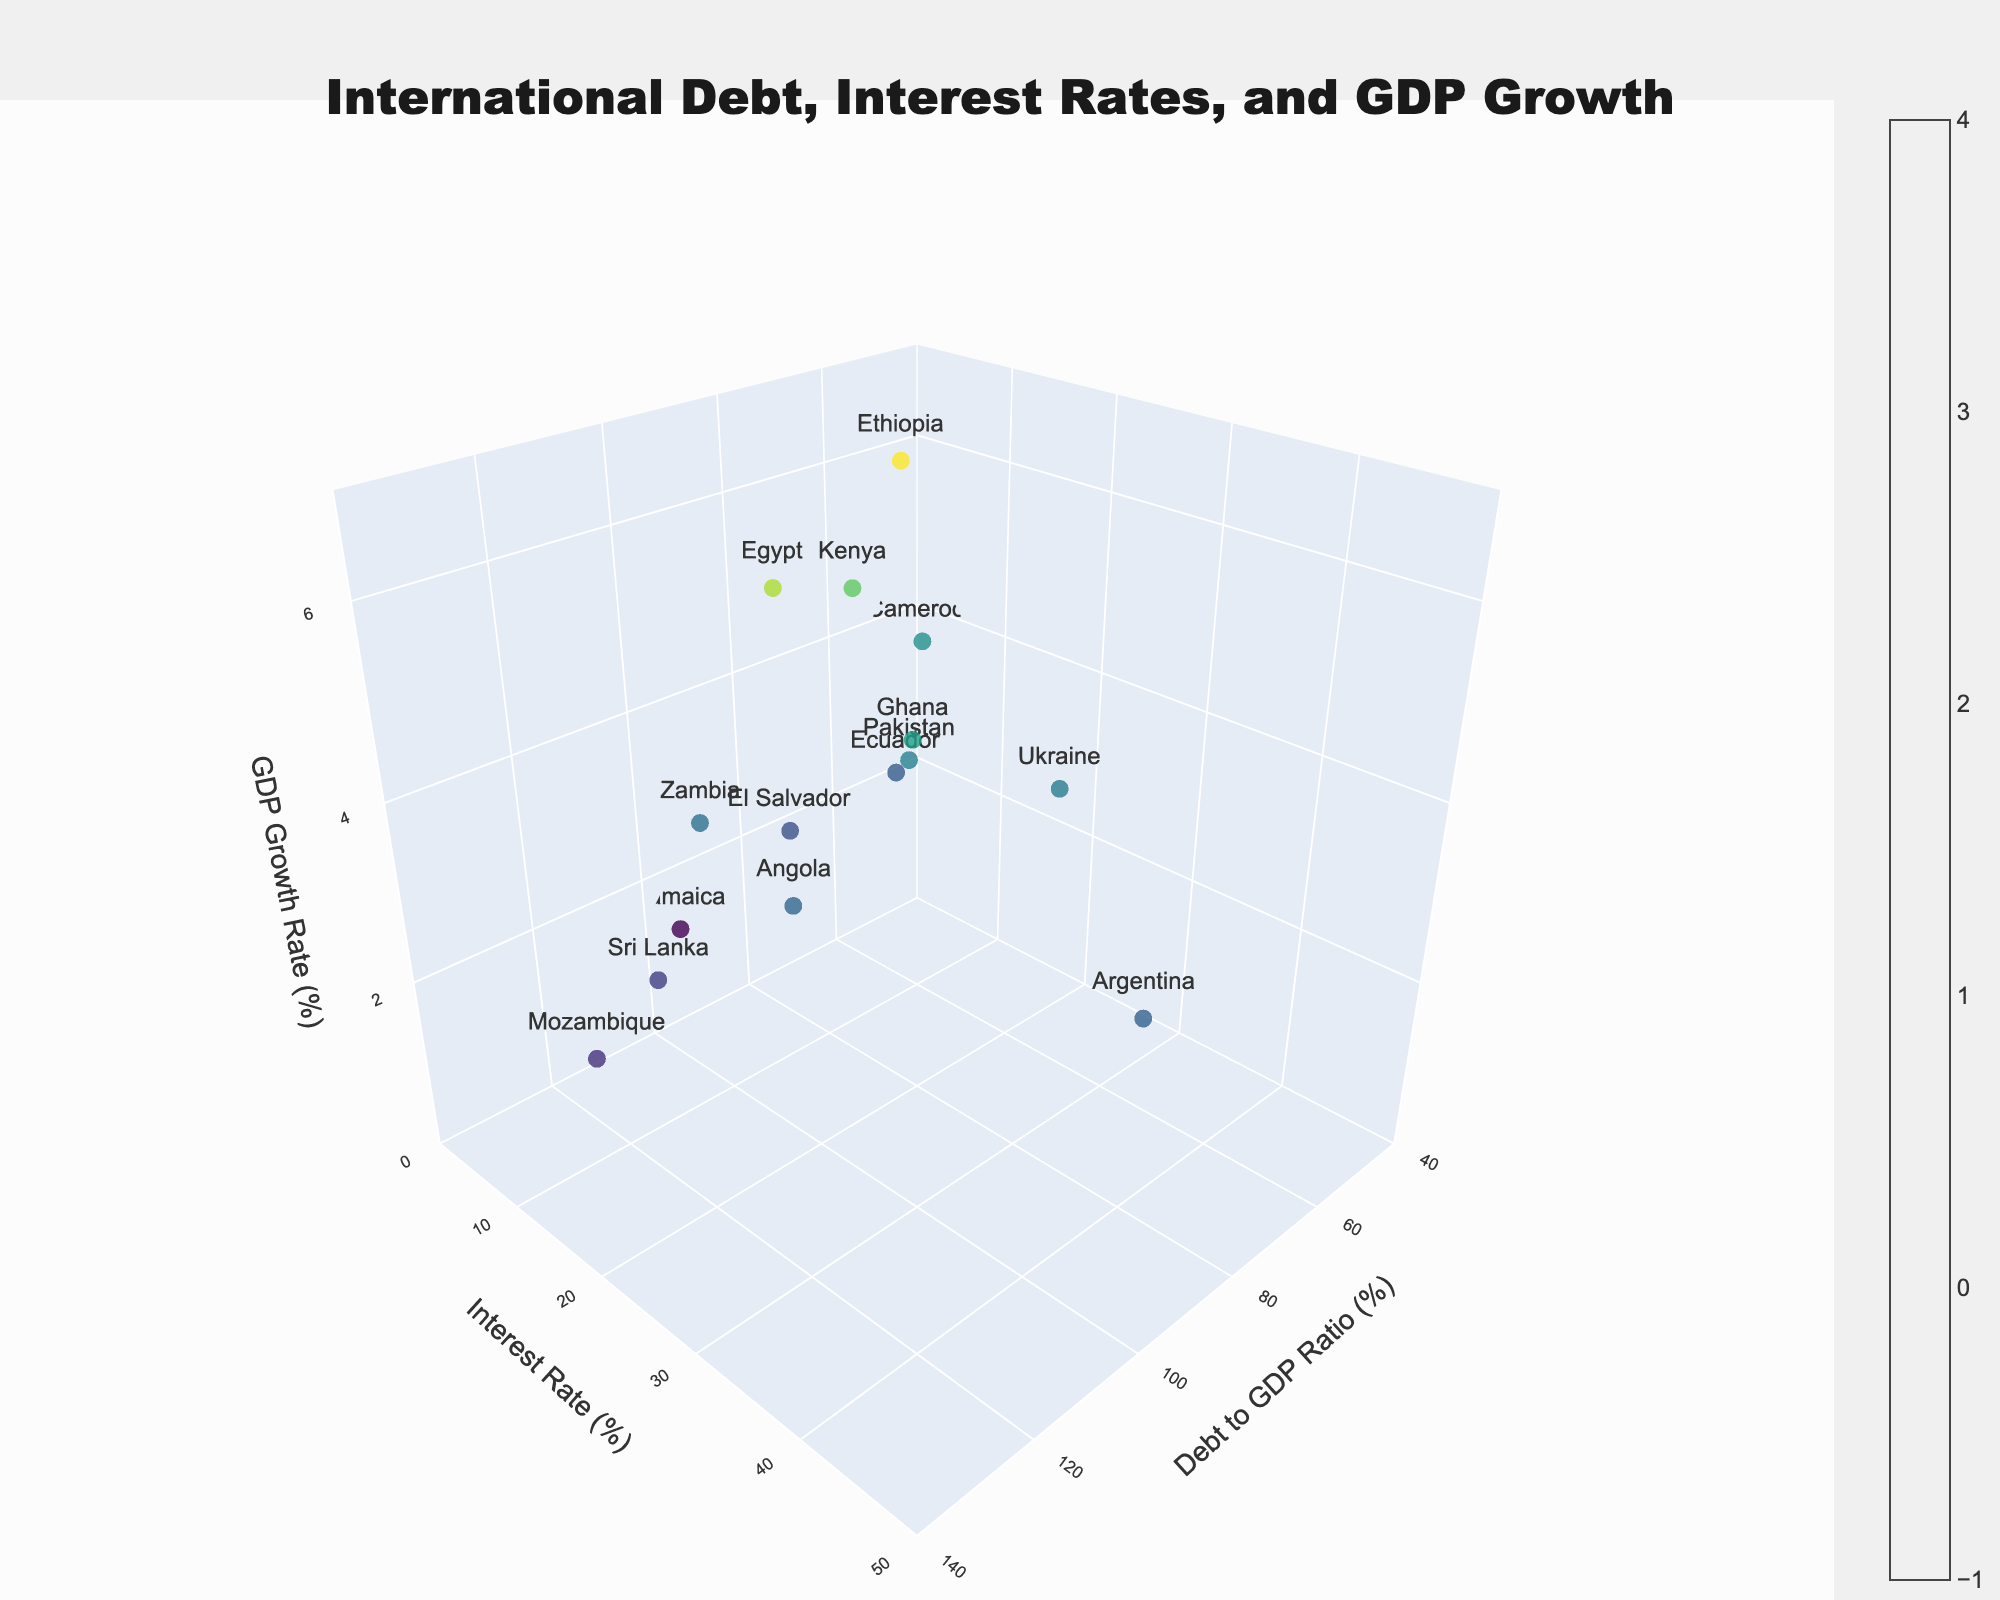What is the title of the plot? The title is displayed at the top of the plot, which in this case reads 'International Debt, Interest Rates, and GDP Growth'
Answer: International Debt, Interest Rates, and GDP Growth How many countries are included in the plot? Each country is represented by a scatter point in the plot. By counting these points, you will see there are 15.
Answer: 15 What is the GDP growth rate of Ethiopia? Locate Ethiopia's marked point in the plot and refer to its position on the z-axis, which represents GDP growth rate.
Answer: 6.2% What range of debt-to-GDP ratios can be observed on the x-axis in the plot? The x-axis ranges from 40 to 140 percent, as indicated by the axis labels.
Answer: 40% to 140% Which country has the highest interest rate? Examine the y-axis positions of all points. Ukraine's marker, at 25.0%, appears highest along the y-axis.
Answer: Ukraine How does the GDP growth rate of Angola compare to that of Argentina? Identify the points for Angola and Argentina. Angola has a growth rate of 3.0%, while Argentina's is 2.9%. Angola's rate is slightly higher.
Answer: Angola's rate is slightly higher What is an average GDP growth rate for countries with a debt-to-GDP ratio above 100%? Calculate the average for Mozambique (2.1%), Sri Lanka (2.3%), Zambia (3.2%), and Angola (3.0%) by summing these values (2.1+2.3+3.2+3.0=10.6) and dividing by 4.
Answer: 2.65% Which country has the lowest debt-to-GDP ratio, and what is its GDP growth rate? Cameroon has the lowest debt-to-GDP ratio (45.8%) by its x-axis position. Its GDP growth rate is 3.8%.
Answer: Cameroon, 3.8% What is the relationship between debt-to-GDP ratios and GDP growth rates? Visual inspection shows points with higher debt-to-GDP ratios don't consistently result in higher or lower GDP growth rates, indicating no clear trend.
Answer: No clear trend 